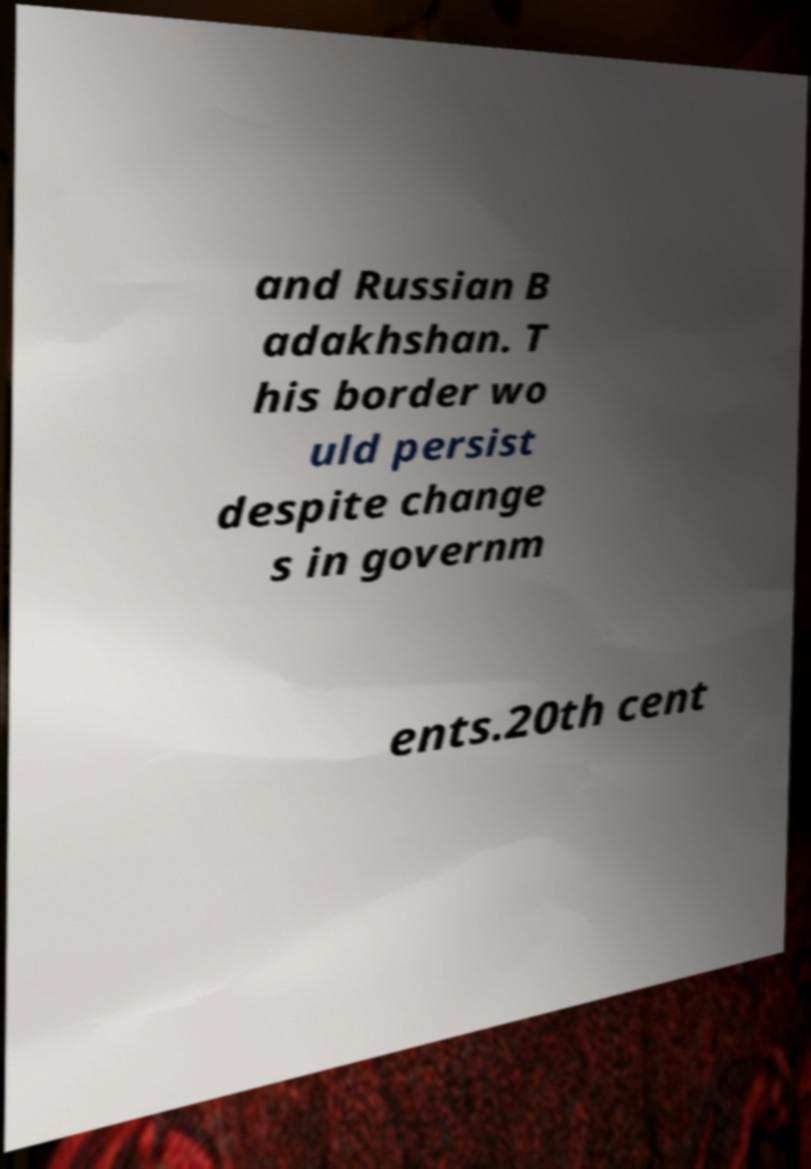Please identify and transcribe the text found in this image. and Russian B adakhshan. T his border wo uld persist despite change s in governm ents.20th cent 